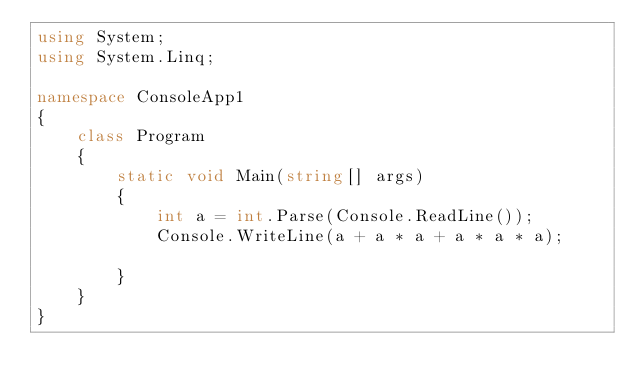<code> <loc_0><loc_0><loc_500><loc_500><_C#_>using System;
using System.Linq;

namespace ConsoleApp1
{
    class Program
    {
        static void Main(string[] args)
        {
            int a = int.Parse(Console.ReadLine());
            Console.WriteLine(a + a * a + a * a * a);
            
        }    
    }
}
</code> 